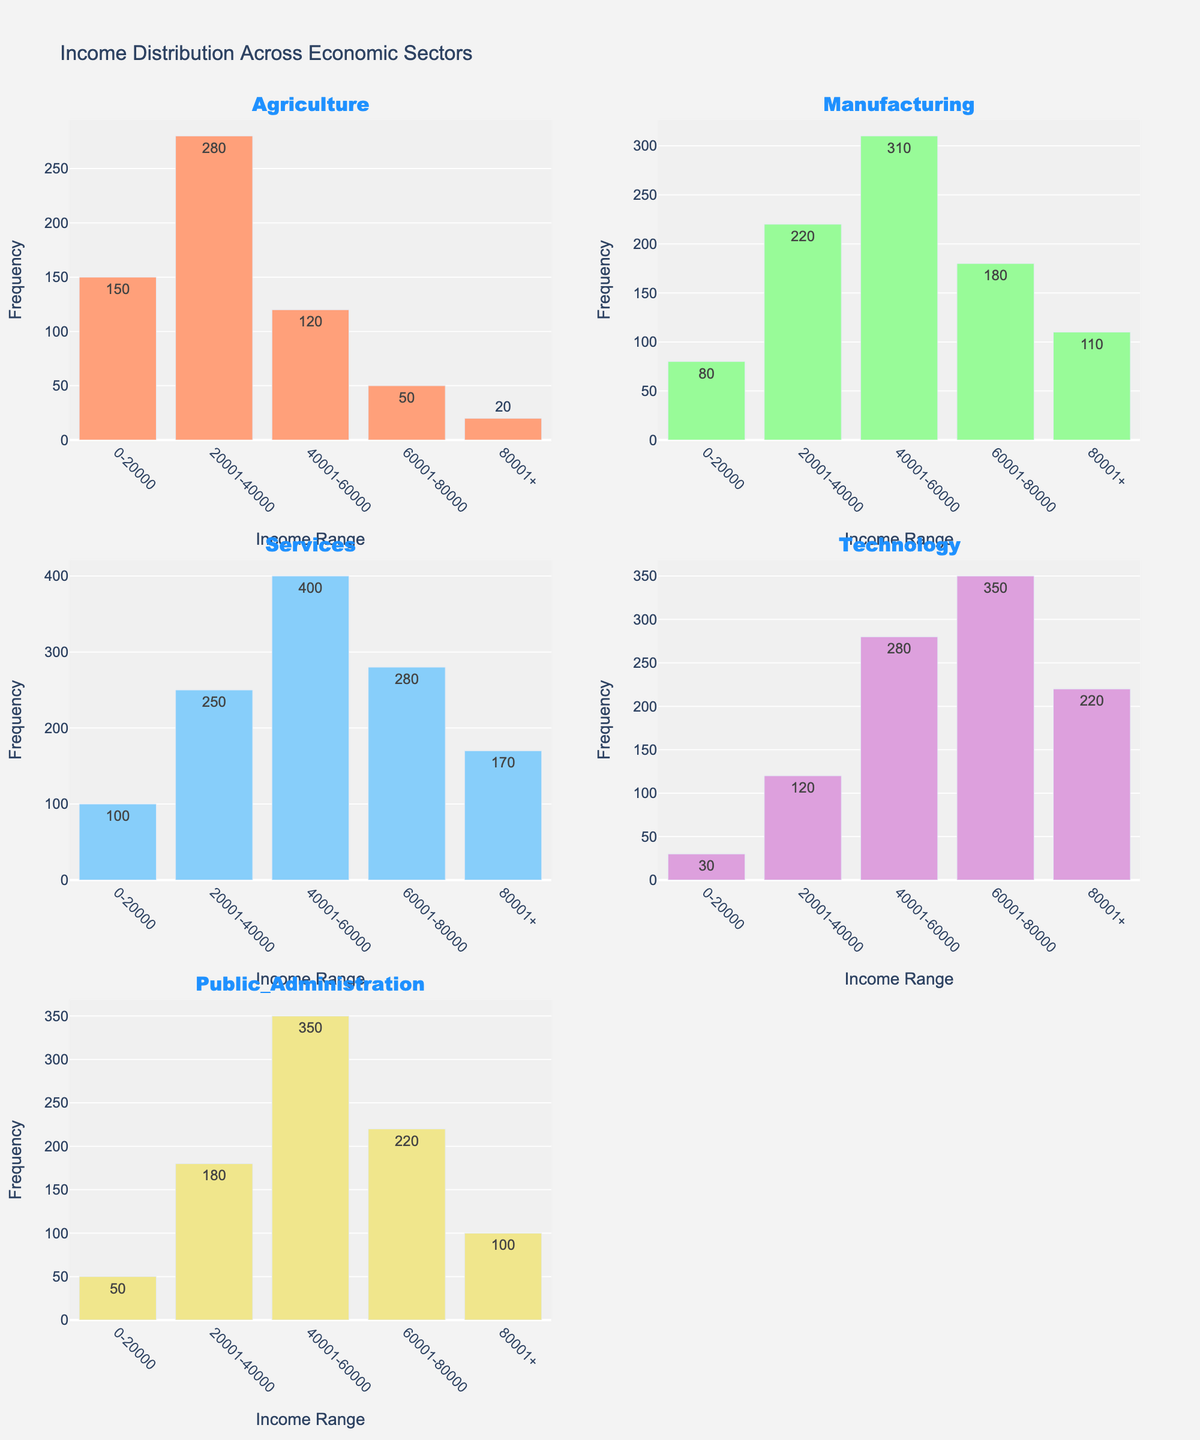What is the title of the figure? The title of a figure is typically displayed at the top center of the plot. Checking the center top region, we can see the text "Income Distribution Across Economic Sectors".
Answer: Income Distribution Across Economic Sectors What is the frequency of the highest income range in the Technology sector? Locate the Technology sector subplot and find the bar corresponding to the income range "80001+". The height of this bar indicates the frequency, which is labeled as 220.
Answer: 220 In which sector is the least number of people in the 0-20000 income range? Compare the heights of the bars in the 0-20000 income range across all sectors. The shortest bar is in the Technology sector, indicating the least number of people, labeled with a frequency of 30.
Answer: Technology Which sector has the most even distribution of income across the different ranges? To determine even distribution, we look for the sector with bars of similar heights across income ranges. The Agriculture sector has relatively similar heights across different income ranges, indicating a more even distribution.
Answer: Agriculture What is the total frequency of individuals earning between 40001 and 60000 in the Manufacturing and Services sectors combined? Sum the frequencies for the 40001-60000 income range in both the Manufacturing (310) and Services (400) sectors: 310 + 400 = 710.
Answer: 710 Which sector has the highest frequency in the income range of 60001-80000? Compare the heights of the bars in the 60001-80000 income range across all sectors. The tallest bar in this range is in the Technology sector with a frequency of 350.
Answer: Technology How many people in the Public Administration sector earn less than 60000? Add the frequencies for the 0-20000 (50), 20001-40000 (180), and 40001-60000 (350) income ranges in the Public Administration sector: 50 + 180 + 350 = 580.
Answer: 580 Which income range has the largest frequency across all sectors? Compare the heights of bars across all income ranges and sectors. The tallest bar is in the Services sector for the 40001-60000 income range with a frequency of 400.
Answer: 40001-60000 in Services In the Agriculture sector, how many people earn more than 40000? Sum the frequencies for the 40001-60000 (120), 60001-80000 (50), and 80001+ (20) income ranges in the Agriculture sector: 120 + 50 + 20 = 190.
Answer: 190 